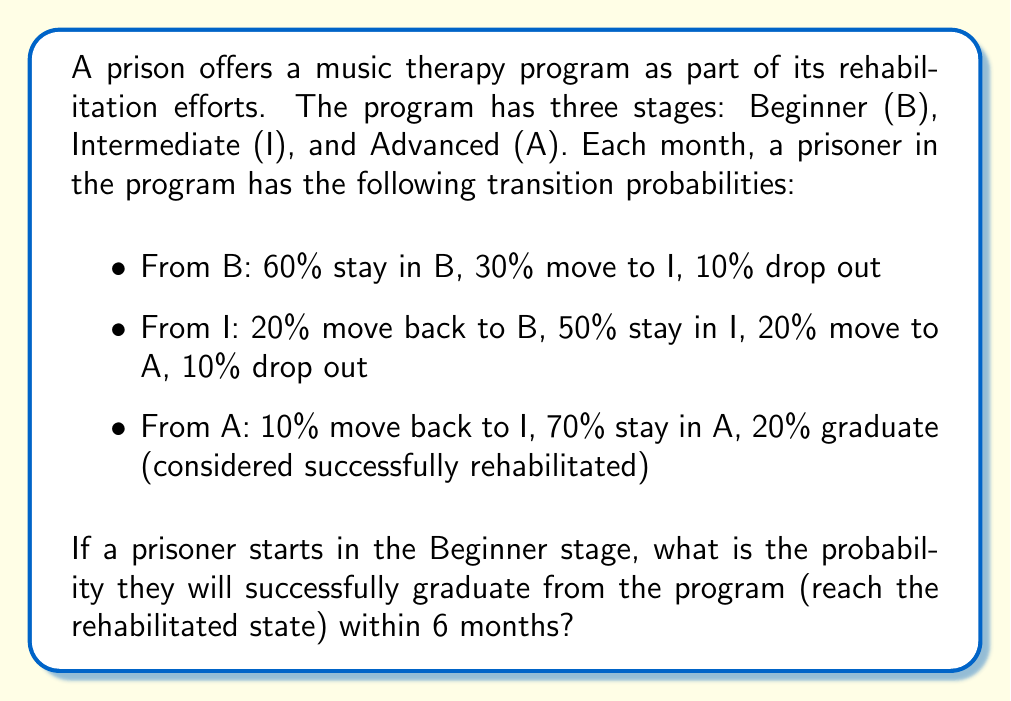What is the answer to this math problem? To solve this problem, we'll use a Markov chain model with the following states:
B (Beginner), I (Intermediate), A (Advanced), D (Dropout), and R (Rehabilitated).

Step 1: Set up the transition probability matrix P.

$$P = \begin{bmatrix}
0.6 & 0.3 & 0 & 0.1 & 0 \\
0.2 & 0.5 & 0.2 & 0.1 & 0 \\
0 & 0.1 & 0.7 & 0 & 0.2 \\
0 & 0 & 0 & 1 & 0 \\
0 & 0 & 0 & 0 & 1
\end{bmatrix}$$

Step 2: Calculate $P^6$ (6-month transition probabilities) using matrix multiplication.

$$P^6 = \begin{bmatrix}
0.1499 & 0.2183 & 0.2183 & 0.2555 & 0.1580 \\
0.1201 & 0.1975 & 0.2537 & 0.2455 & 0.1832 \\
0.0469 & 0.1031 & 0.3495 & 0.1148 & 0.3857 \\
0 & 0 & 0 & 1 & 0 \\
0 & 0 & 0 & 0 & 1
\end{bmatrix}$$

Step 3: The probability of successful rehabilitation starting from B is given by the element in the first row, last column of $P^6$.

Probability = 0.1580 or 15.80%
Answer: 0.1580 